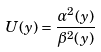<formula> <loc_0><loc_0><loc_500><loc_500>U ( y ) = \frac { \alpha ^ { 2 } ( y ) } { \beta ^ { 2 } ( y ) }</formula> 